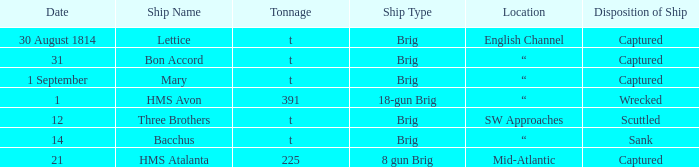With a tonnage of t, what type of ship was bacchus? Sank. 